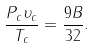<formula> <loc_0><loc_0><loc_500><loc_500>\frac { P _ { c } \upsilon _ { c } } { T _ { c } } = \frac { 9 B } { 3 2 } .</formula> 